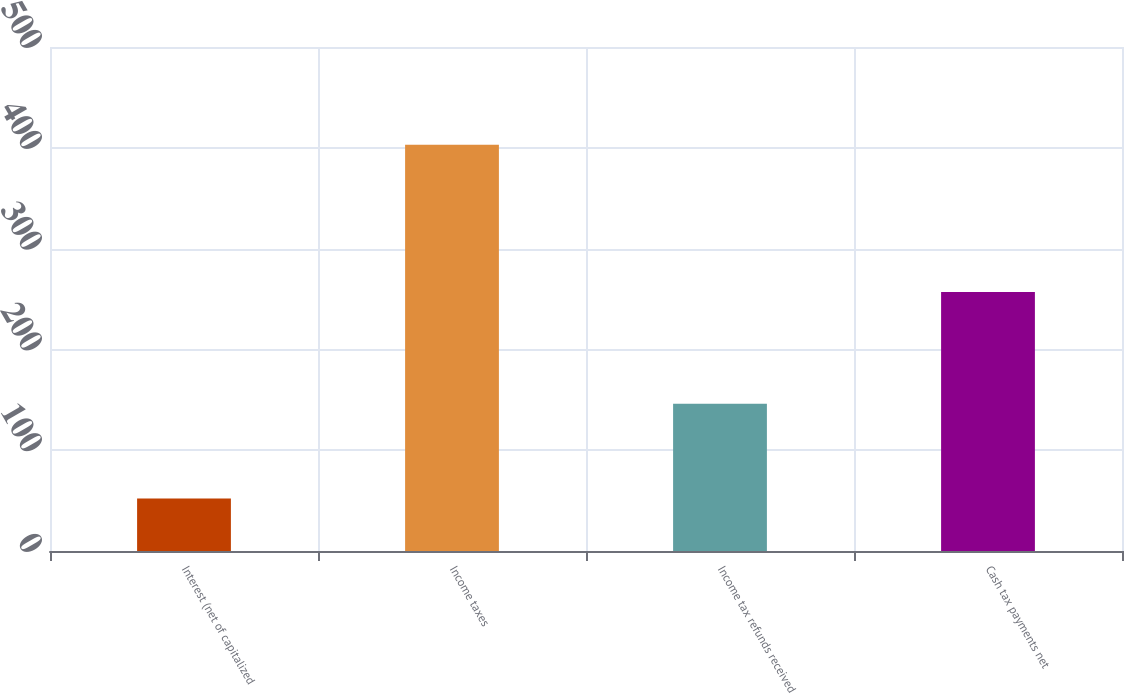<chart> <loc_0><loc_0><loc_500><loc_500><bar_chart><fcel>Interest (net of capitalized<fcel>Income taxes<fcel>Income tax refunds received<fcel>Cash tax payments net<nl><fcel>52<fcel>403<fcel>146<fcel>257<nl></chart> 